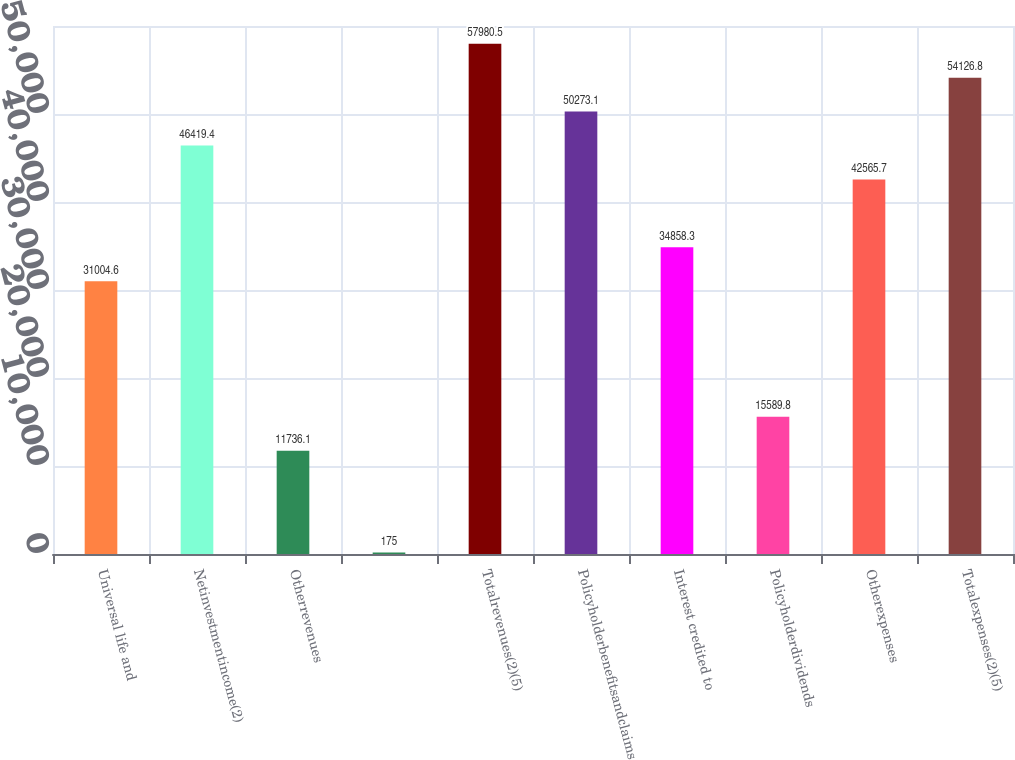Convert chart. <chart><loc_0><loc_0><loc_500><loc_500><bar_chart><fcel>Universal life and<fcel>Netinvestmentincome(2)<fcel>Otherrevenues<fcel>Unnamed: 3<fcel>Totalrevenues(2)(5)<fcel>Policyholderbenefitsandclaims<fcel>Interest credited to<fcel>Policyholderdividends<fcel>Otherexpenses<fcel>Totalexpenses(2)(5)<nl><fcel>31004.6<fcel>46419.4<fcel>11736.1<fcel>175<fcel>57980.5<fcel>50273.1<fcel>34858.3<fcel>15589.8<fcel>42565.7<fcel>54126.8<nl></chart> 